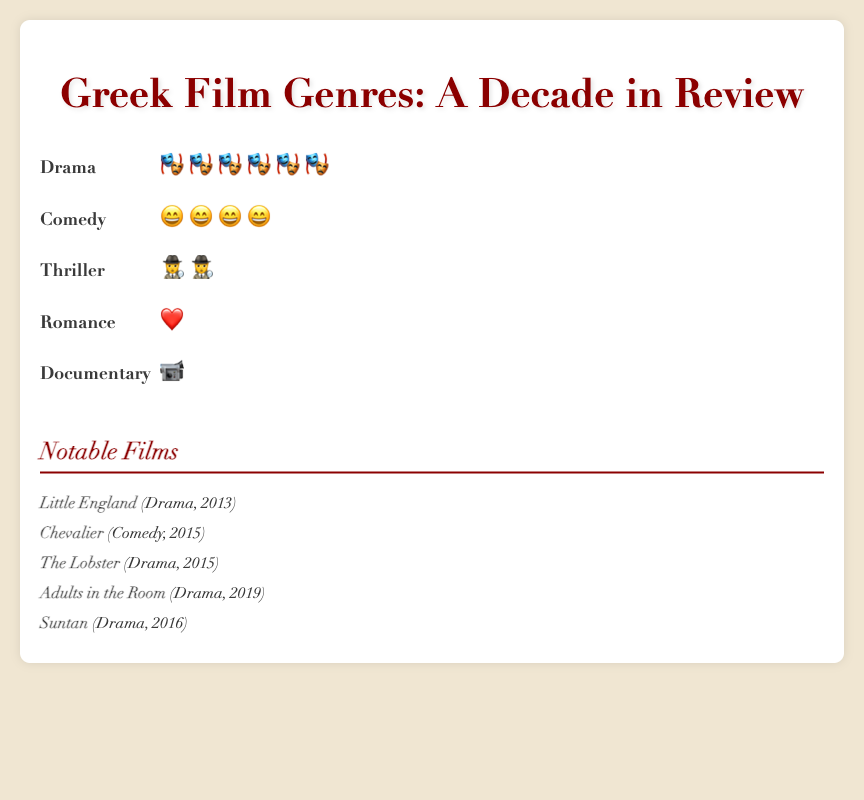Which genre has the highest number of films released in the last decade? The isotype plot shows icons representing the number of films for each genre. Observing the number of icons, Drama has the most with six theater masks.
Answer: Drama What is the combined number of Drama and Comedy films released? To find the total, add the number of icons for Drama (120) and Comedy (85). 120 + 85 = 205
Answer: 205 Which genre has fewer films released: Thriller or Romance? By counting the respective icons, Thriller has 40 and Romance has 30. Since 30 is less than 40, Romance has fewer films.
Answer: Romance How does the number of Comedy films compare to Documentary films? Comedy has 85 icons, while Documentary has 25. 85 is greater than 25.
Answer: Comedy has more films By how much do Drama genre films outnumber Comedy genre films? Subtract the number of Comedy films (85) from Drama films (120). 120 - 85 = 35
Answer: 35 Which notable film is categorized as Comedy? From the listed notable films, "Chevalier" is listed under Comedy.
Answer: Chevalier What is the color associated with the Drama genre in the isotype plot? The icons representing Drama films are colored in a dark red (#8b0000).
Answer: Dark red How many different genres are represented in the plot? Count the different genre names: Drama, Comedy, Thriller, Romance, Documentary. There are 5 genres.
Answer: 5 Which genre has the least number of films released? The genre with the least icons (1 each) is Documentary, represented by 25 icons.
Answer: Documentary Name three notable Drama films mentioned in the figure. The listed notable Drama films are "Little England", "The Lobster", and "Adults in the Room".
Answer: Little England, The Lobster, Adults in the Room 